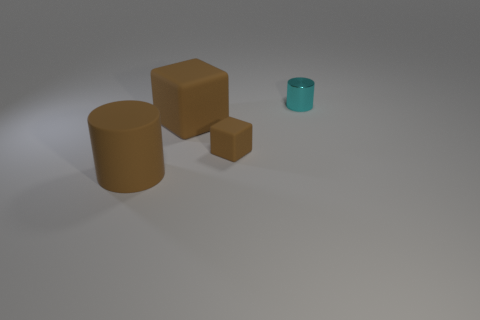Add 1 rubber objects. How many objects exist? 5 Subtract 1 cyan cylinders. How many objects are left? 3 Subtract all matte blocks. Subtract all tiny cyan shiny cylinders. How many objects are left? 1 Add 1 brown rubber things. How many brown rubber things are left? 4 Add 2 shiny cylinders. How many shiny cylinders exist? 3 